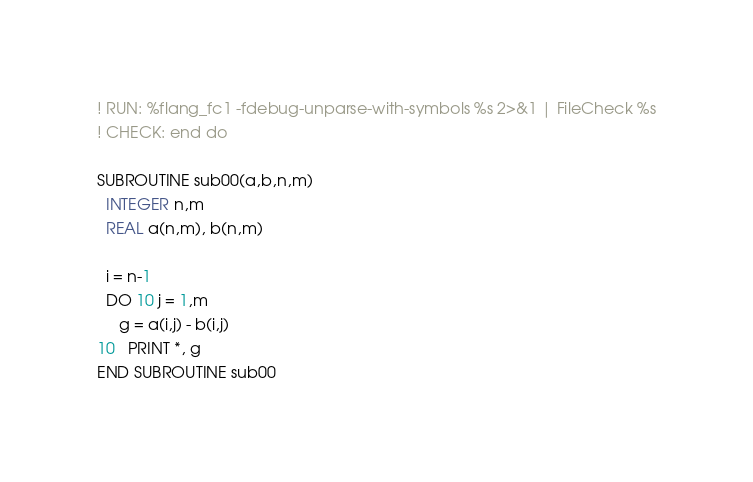<code> <loc_0><loc_0><loc_500><loc_500><_FORTRAN_>! RUN: %flang_fc1 -fdebug-unparse-with-symbols %s 2>&1 | FileCheck %s
! CHECK: end do

SUBROUTINE sub00(a,b,n,m)
  INTEGER n,m
  REAL a(n,m), b(n,m)

  i = n-1
  DO 10 j = 1,m
     g = a(i,j) - b(i,j)
10   PRINT *, g
END SUBROUTINE sub00
</code> 